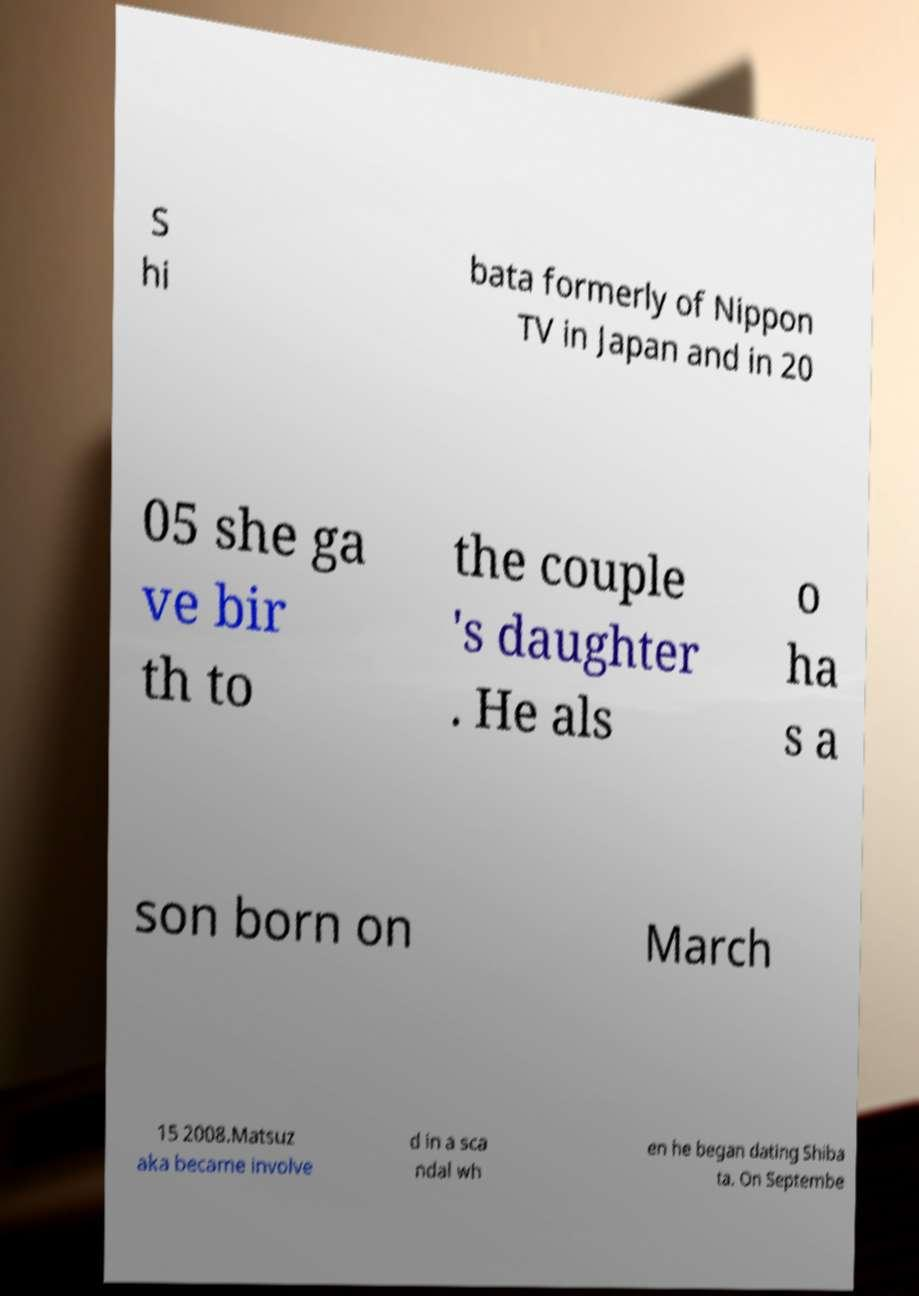Please read and relay the text visible in this image. What does it say? S hi bata formerly of Nippon TV in Japan and in 20 05 she ga ve bir th to the couple 's daughter . He als o ha s a son born on March 15 2008.Matsuz aka became involve d in a sca ndal wh en he began dating Shiba ta. On Septembe 